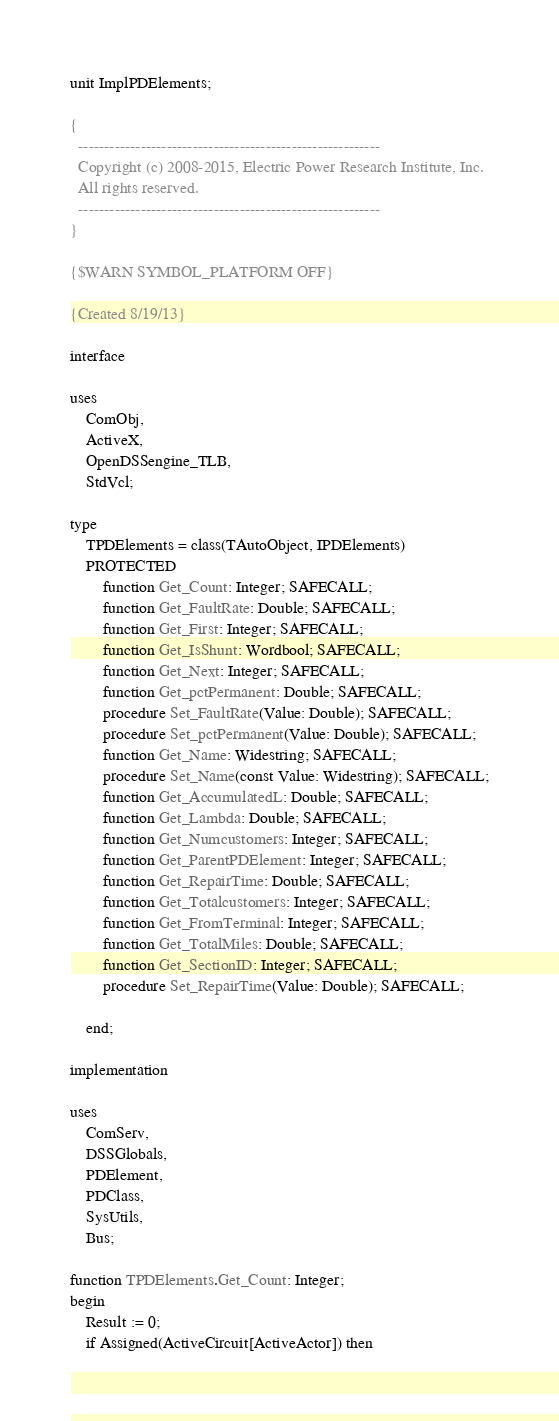<code> <loc_0><loc_0><loc_500><loc_500><_Pascal_>unit ImplPDElements;

{
  ----------------------------------------------------------
  Copyright (c) 2008-2015, Electric Power Research Institute, Inc.
  All rights reserved.
  ----------------------------------------------------------
}

{$WARN SYMBOL_PLATFORM OFF}

{Created 8/19/13}

interface

uses
    ComObj,
    ActiveX,
    OpenDSSengine_TLB,
    StdVcl;

type
    TPDElements = class(TAutoObject, IPDElements)
    PROTECTED
        function Get_Count: Integer; SAFECALL;
        function Get_FaultRate: Double; SAFECALL;
        function Get_First: Integer; SAFECALL;
        function Get_IsShunt: Wordbool; SAFECALL;
        function Get_Next: Integer; SAFECALL;
        function Get_pctPermanent: Double; SAFECALL;
        procedure Set_FaultRate(Value: Double); SAFECALL;
        procedure Set_pctPermanent(Value: Double); SAFECALL;
        function Get_Name: Widestring; SAFECALL;
        procedure Set_Name(const Value: Widestring); SAFECALL;
        function Get_AccumulatedL: Double; SAFECALL;
        function Get_Lambda: Double; SAFECALL;
        function Get_Numcustomers: Integer; SAFECALL;
        function Get_ParentPDElement: Integer; SAFECALL;
        function Get_RepairTime: Double; SAFECALL;
        function Get_Totalcustomers: Integer; SAFECALL;
        function Get_FromTerminal: Integer; SAFECALL;
        function Get_TotalMiles: Double; SAFECALL;
        function Get_SectionID: Integer; SAFECALL;
        procedure Set_RepairTime(Value: Double); SAFECALL;

    end;

implementation

uses
    ComServ,
    DSSGlobals,
    PDElement,
    PDClass,
    SysUtils,
    Bus;

function TPDElements.Get_Count: Integer;
begin
    Result := 0;
    if Assigned(ActiveCircuit[ActiveActor]) then</code> 